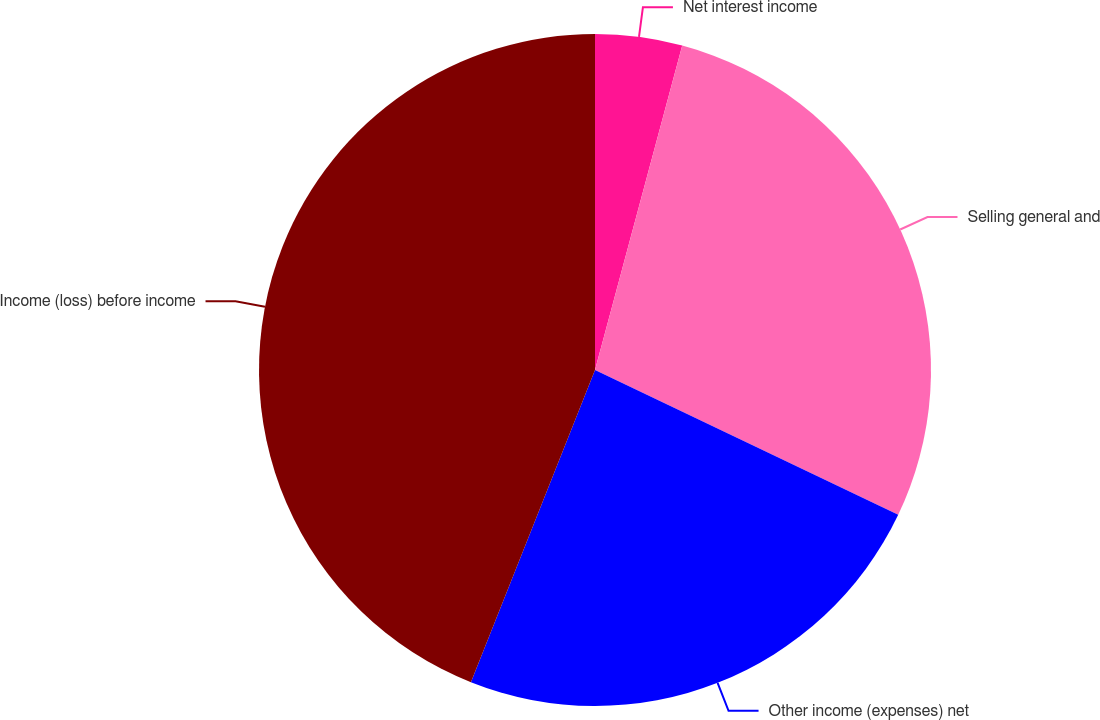<chart> <loc_0><loc_0><loc_500><loc_500><pie_chart><fcel>Net interest income<fcel>Selling general and<fcel>Other income (expenses) net<fcel>Income (loss) before income<nl><fcel>4.18%<fcel>27.91%<fcel>23.93%<fcel>43.98%<nl></chart> 